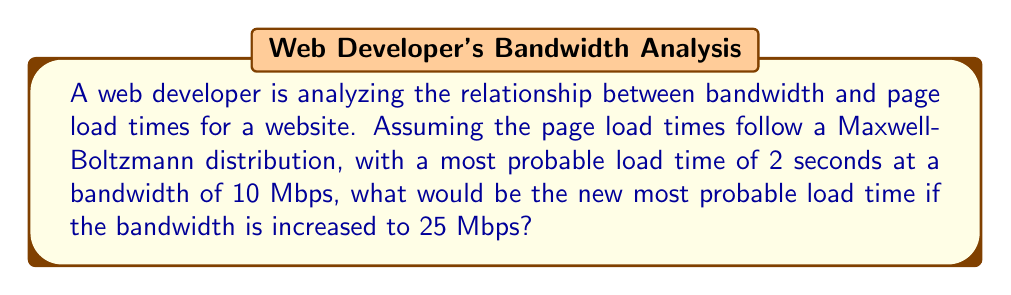Show me your answer to this math problem. To solve this problem, we'll use the Maxwell-Boltzmann distribution and the relationship between bandwidth and page load times. Let's approach this step-by-step:

1. The Maxwell-Boltzmann distribution for page load times can be expressed as:

   $$f(t) = \sqrt{\frac{2}{\pi}} \cdot \frac{t^2}{a^3} \cdot e^{-t^2/(2a^2)}$$

   where $t$ is the load time and $a$ is a parameter related to the most probable load time.

2. The most probable load time $t_p$ is given by:

   $$t_p = a\sqrt{2}$$

3. We're told that at 10 Mbps, $t_p = 2$ seconds. Let's call this $t_{p1}$. So:

   $$t_{p1} = a_1\sqrt{2} = 2$$
   $$a_1 = \frac{2}{\sqrt{2}} = \sqrt{2}$$

4. Now, we need to establish the relationship between bandwidth and load time. In a simplified model, we can assume that load time is inversely proportional to bandwidth:

   $$t \propto \frac{1}{\text{bandwidth}}$$

5. This means that when we increase the bandwidth from 10 Mbps to 25 Mbps, the new most probable load time $t_{p2}$ will be:

   $$\frac{t_{p2}}{t_{p1}} = \frac{10}{25}$$
   $$t_{p2} = t_{p1} \cdot \frac{10}{25} = 2 \cdot \frac{10}{25} = 0.8 \text{ seconds}$$

6. We can verify this by calculating the new parameter $a_2$:

   $$a_2 = \frac{0.8}{\sqrt{2}} = 0.4\sqrt{2}$$

Thus, the new most probable load time when the bandwidth is increased to 25 Mbps is 0.8 seconds.
Answer: 0.8 seconds 